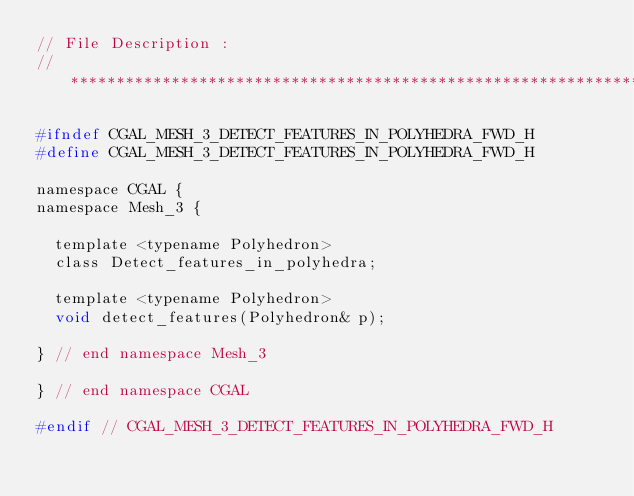<code> <loc_0><loc_0><loc_500><loc_500><_C_>// File Description : 
//******************************************************************************

#ifndef CGAL_MESH_3_DETECT_FEATURES_IN_POLYHEDRA_FWD_H
#define CGAL_MESH_3_DETECT_FEATURES_IN_POLYHEDRA_FWD_H

namespace CGAL {
namespace Mesh_3 {
  
  template <typename Polyhedron>
  class Detect_features_in_polyhedra;

  template <typename Polyhedron>
  void detect_features(Polyhedron& p);
  
} // end namespace Mesh_3
  
} // end namespace CGAL

#endif // CGAL_MESH_3_DETECT_FEATURES_IN_POLYHEDRA_FWD_H
</code> 